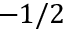Convert formula to latex. <formula><loc_0><loc_0><loc_500><loc_500>- 1 / 2</formula> 